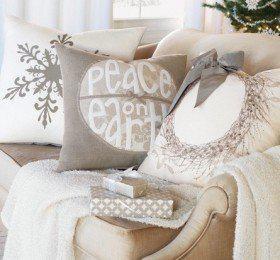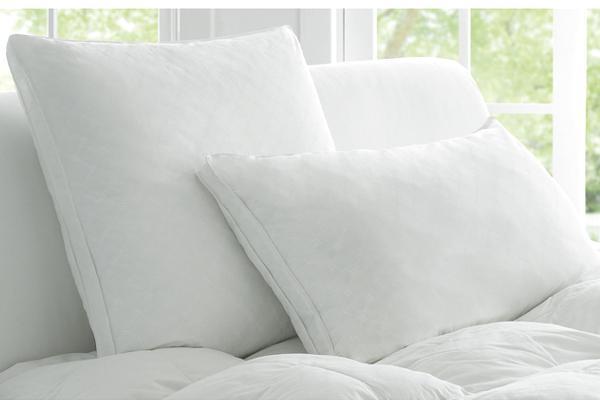The first image is the image on the left, the second image is the image on the right. Assess this claim about the two images: "The headboard in the image on the left is upholstered.". Correct or not? Answer yes or no. No. 